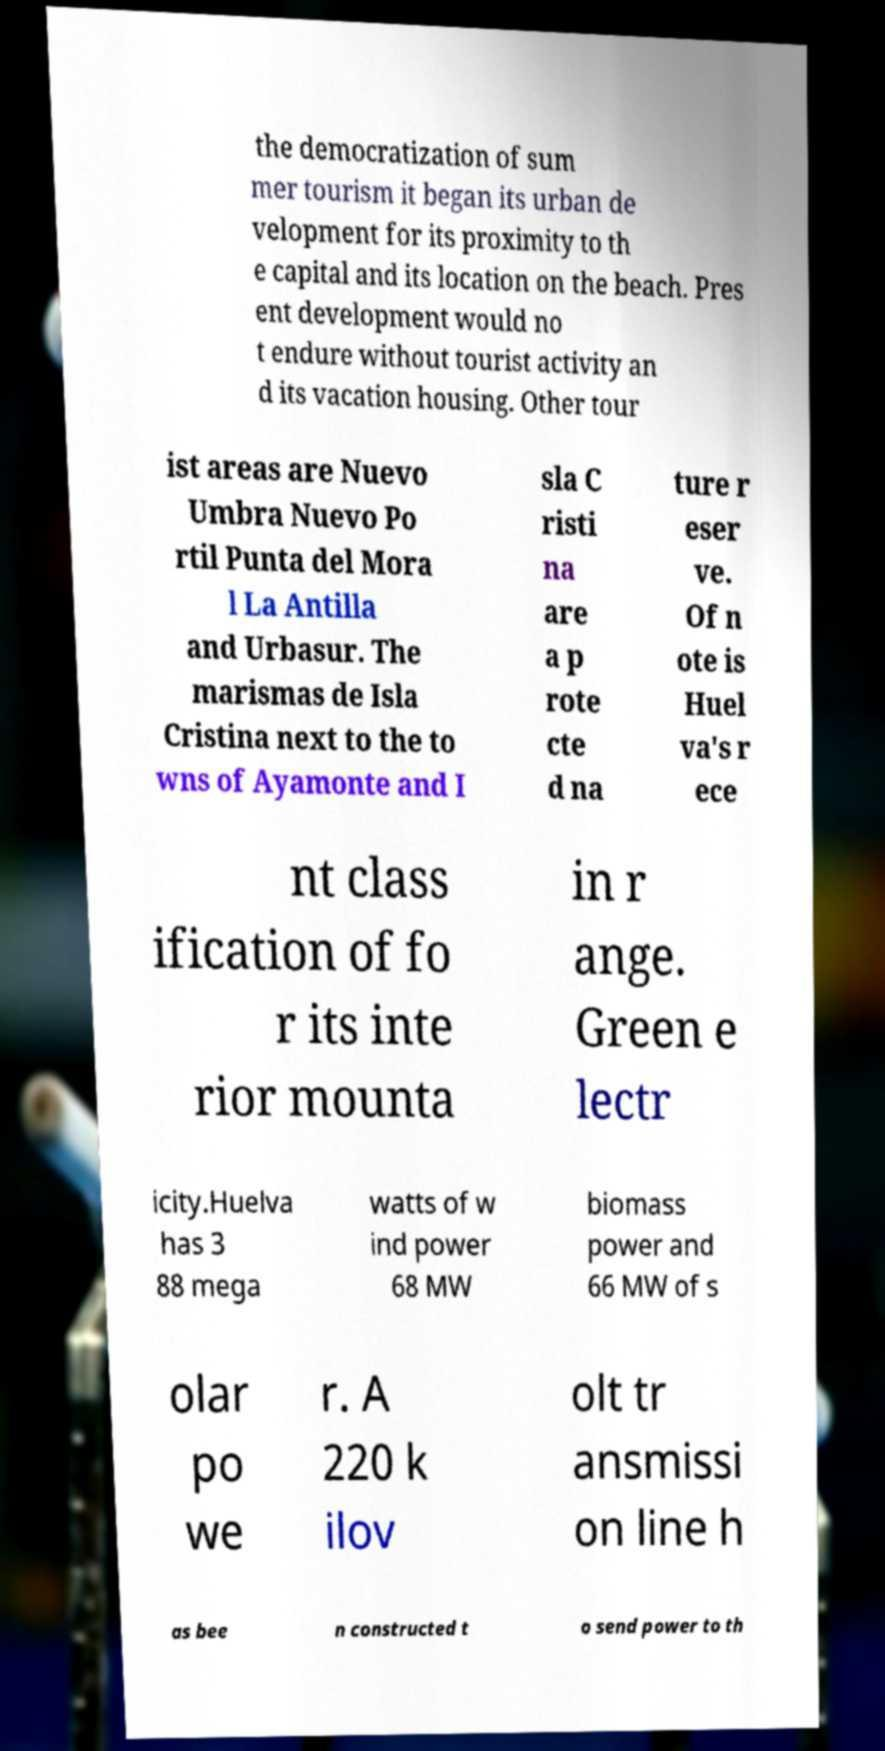Can you read and provide the text displayed in the image?This photo seems to have some interesting text. Can you extract and type it out for me? the democratization of sum mer tourism it began its urban de velopment for its proximity to th e capital and its location on the beach. Pres ent development would no t endure without tourist activity an d its vacation housing. Other tour ist areas are Nuevo Umbra Nuevo Po rtil Punta del Mora l La Antilla and Urbasur. The marismas de Isla Cristina next to the to wns of Ayamonte and I sla C risti na are a p rote cte d na ture r eser ve. Of n ote is Huel va's r ece nt class ification of fo r its inte rior mounta in r ange. Green e lectr icity.Huelva has 3 88 mega watts of w ind power 68 MW biomass power and 66 MW of s olar po we r. A 220 k ilov olt tr ansmissi on line h as bee n constructed t o send power to th 